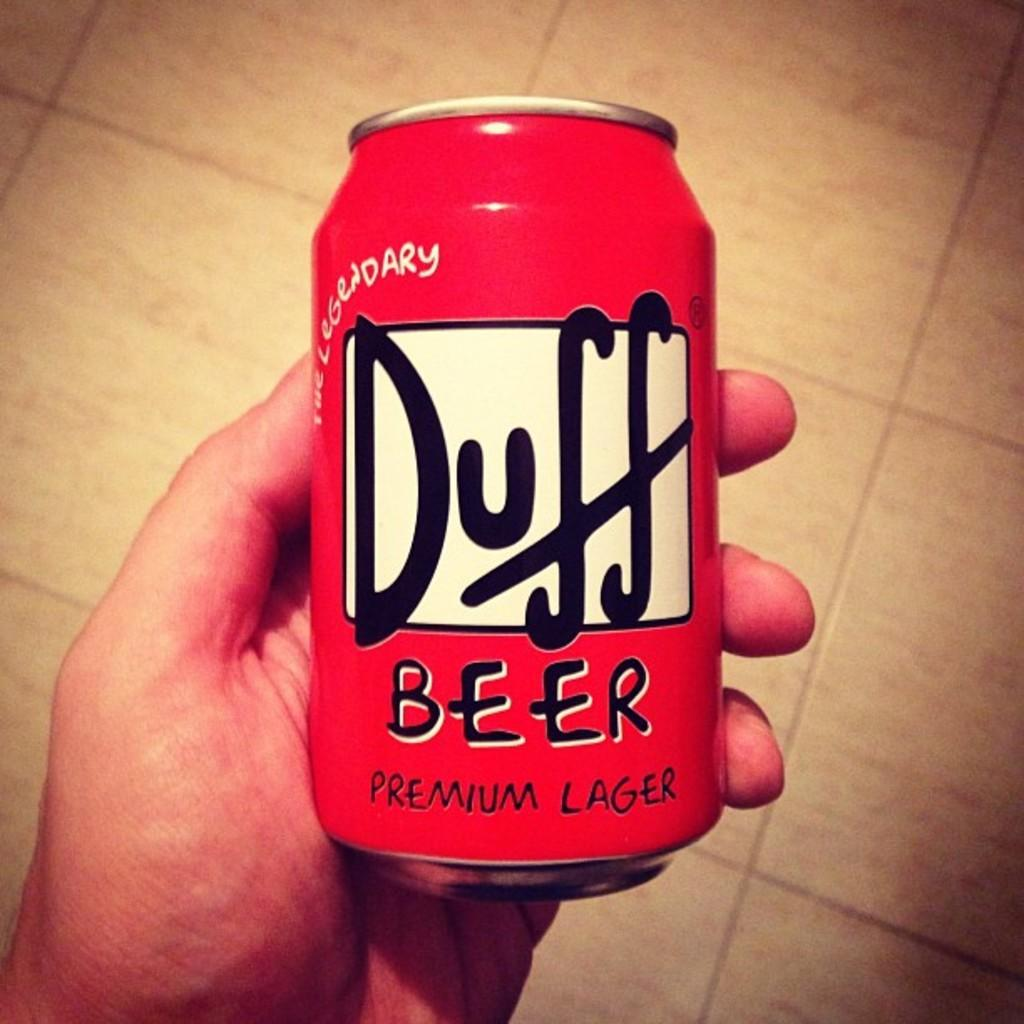<image>
Share a concise interpretation of the image provided. A can of Duff Beer Premium Lager being held in a person's left hand. 